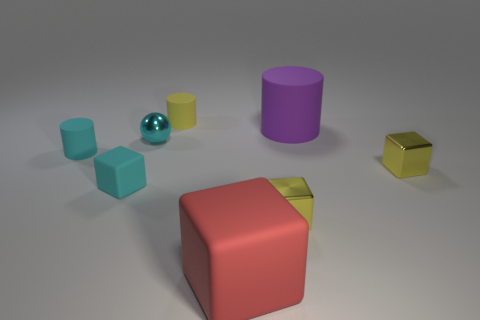Does the small shiny sphere have the same color as the cylinder in front of the tiny cyan metal thing?
Provide a short and direct response. Yes. How many small yellow metallic things are the same shape as the purple thing?
Your answer should be very brief. 0. There is a small yellow thing that is in front of the small cyan block; what material is it?
Provide a succinct answer. Metal. There is a matte thing behind the large purple rubber thing; does it have the same shape as the purple thing?
Make the answer very short. Yes. Are there any red rubber objects of the same size as the cyan matte block?
Your answer should be very brief. No. There is a big purple rubber thing; does it have the same shape as the small yellow thing that is to the left of the big red matte thing?
Keep it short and to the point. Yes. There is a rubber thing that is the same color as the small matte block; what shape is it?
Give a very brief answer. Cylinder. Is the number of red blocks to the left of the tiny cyan metal object less than the number of small green matte cylinders?
Offer a very short reply. No. Is the purple object the same shape as the large red thing?
Your answer should be very brief. No. What is the size of the other block that is the same material as the large block?
Provide a succinct answer. Small. 